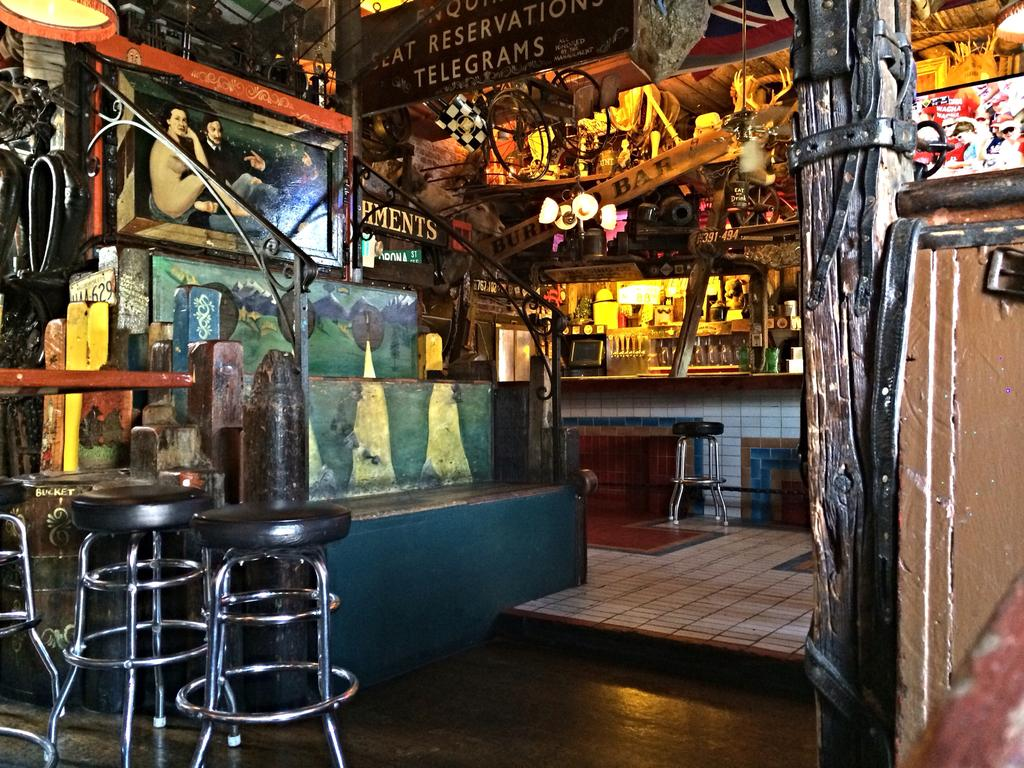What type of furniture is present in the image? There are two black stools in the image. What can be seen on the wall in the background? There is a frame attached to the wall in the background. How would you describe the appearance of the wall? The wall has a multi-colored pattern. What can be used for illumination in the image? There are lights visible in the image. What arithmetic problem is being solved on the stools in the image? There is no arithmetic problem visible on the stools in the image. How does the cart help in transporting the stools in the image? There is no cart present in the image, so it cannot help in transporting the stools. 